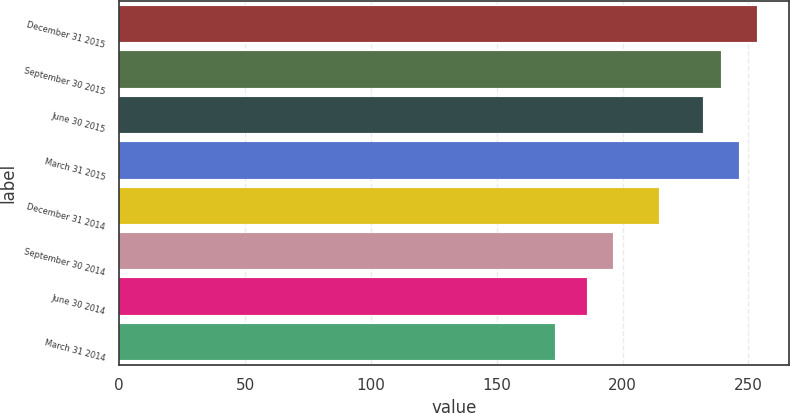Convert chart to OTSL. <chart><loc_0><loc_0><loc_500><loc_500><bar_chart><fcel>December 31 2015<fcel>September 30 2015<fcel>June 30 2015<fcel>March 31 2015<fcel>December 31 2014<fcel>September 30 2014<fcel>June 30 2014<fcel>March 31 2014<nl><fcel>253.41<fcel>239.07<fcel>231.9<fcel>246.24<fcel>214.43<fcel>196.08<fcel>185.99<fcel>173.01<nl></chart> 